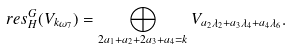Convert formula to latex. <formula><loc_0><loc_0><loc_500><loc_500>\ r e s ^ { G } _ { H } ( V _ { k \omega _ { 7 } } ) = \bigoplus _ { 2 a _ { 1 } + a _ { 2 } + 2 a _ { 3 } + a _ { 4 } = k } V _ { a _ { 2 } \lambda _ { 2 } + a _ { 3 } \lambda _ { 4 } + a _ { 4 } \lambda _ { 6 } } .</formula> 